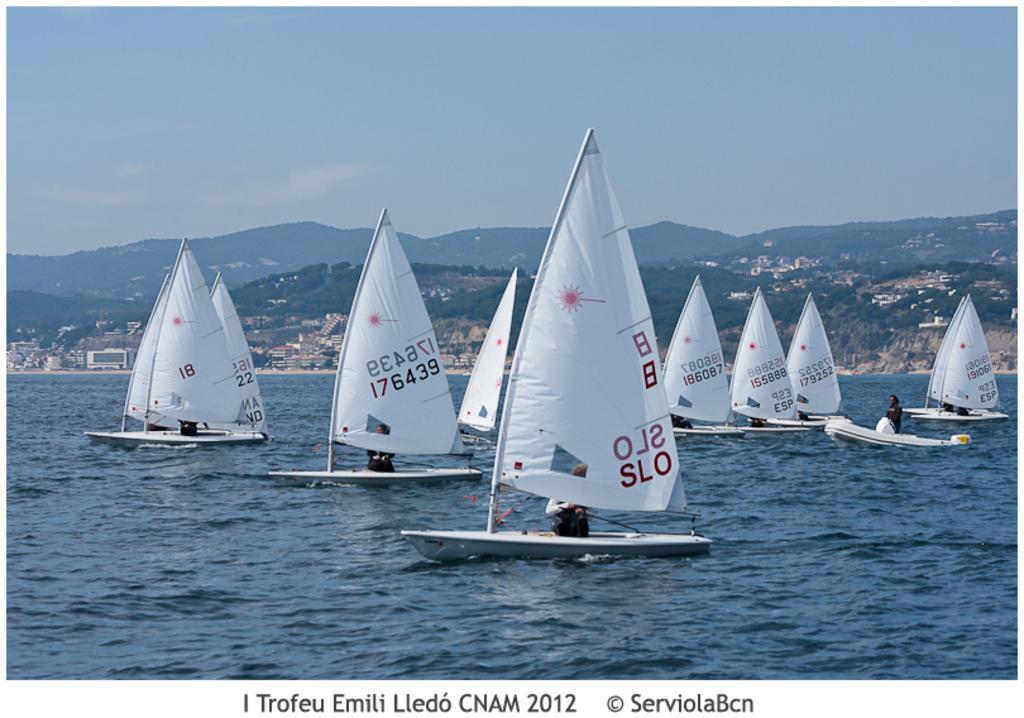In one or two sentences, can you explain what this image depicts? In this picture we can see some people on the boat and the boats are on the water. Behind the boats there are trees, buildings, hills and the sky. On the image there is a watermark. 